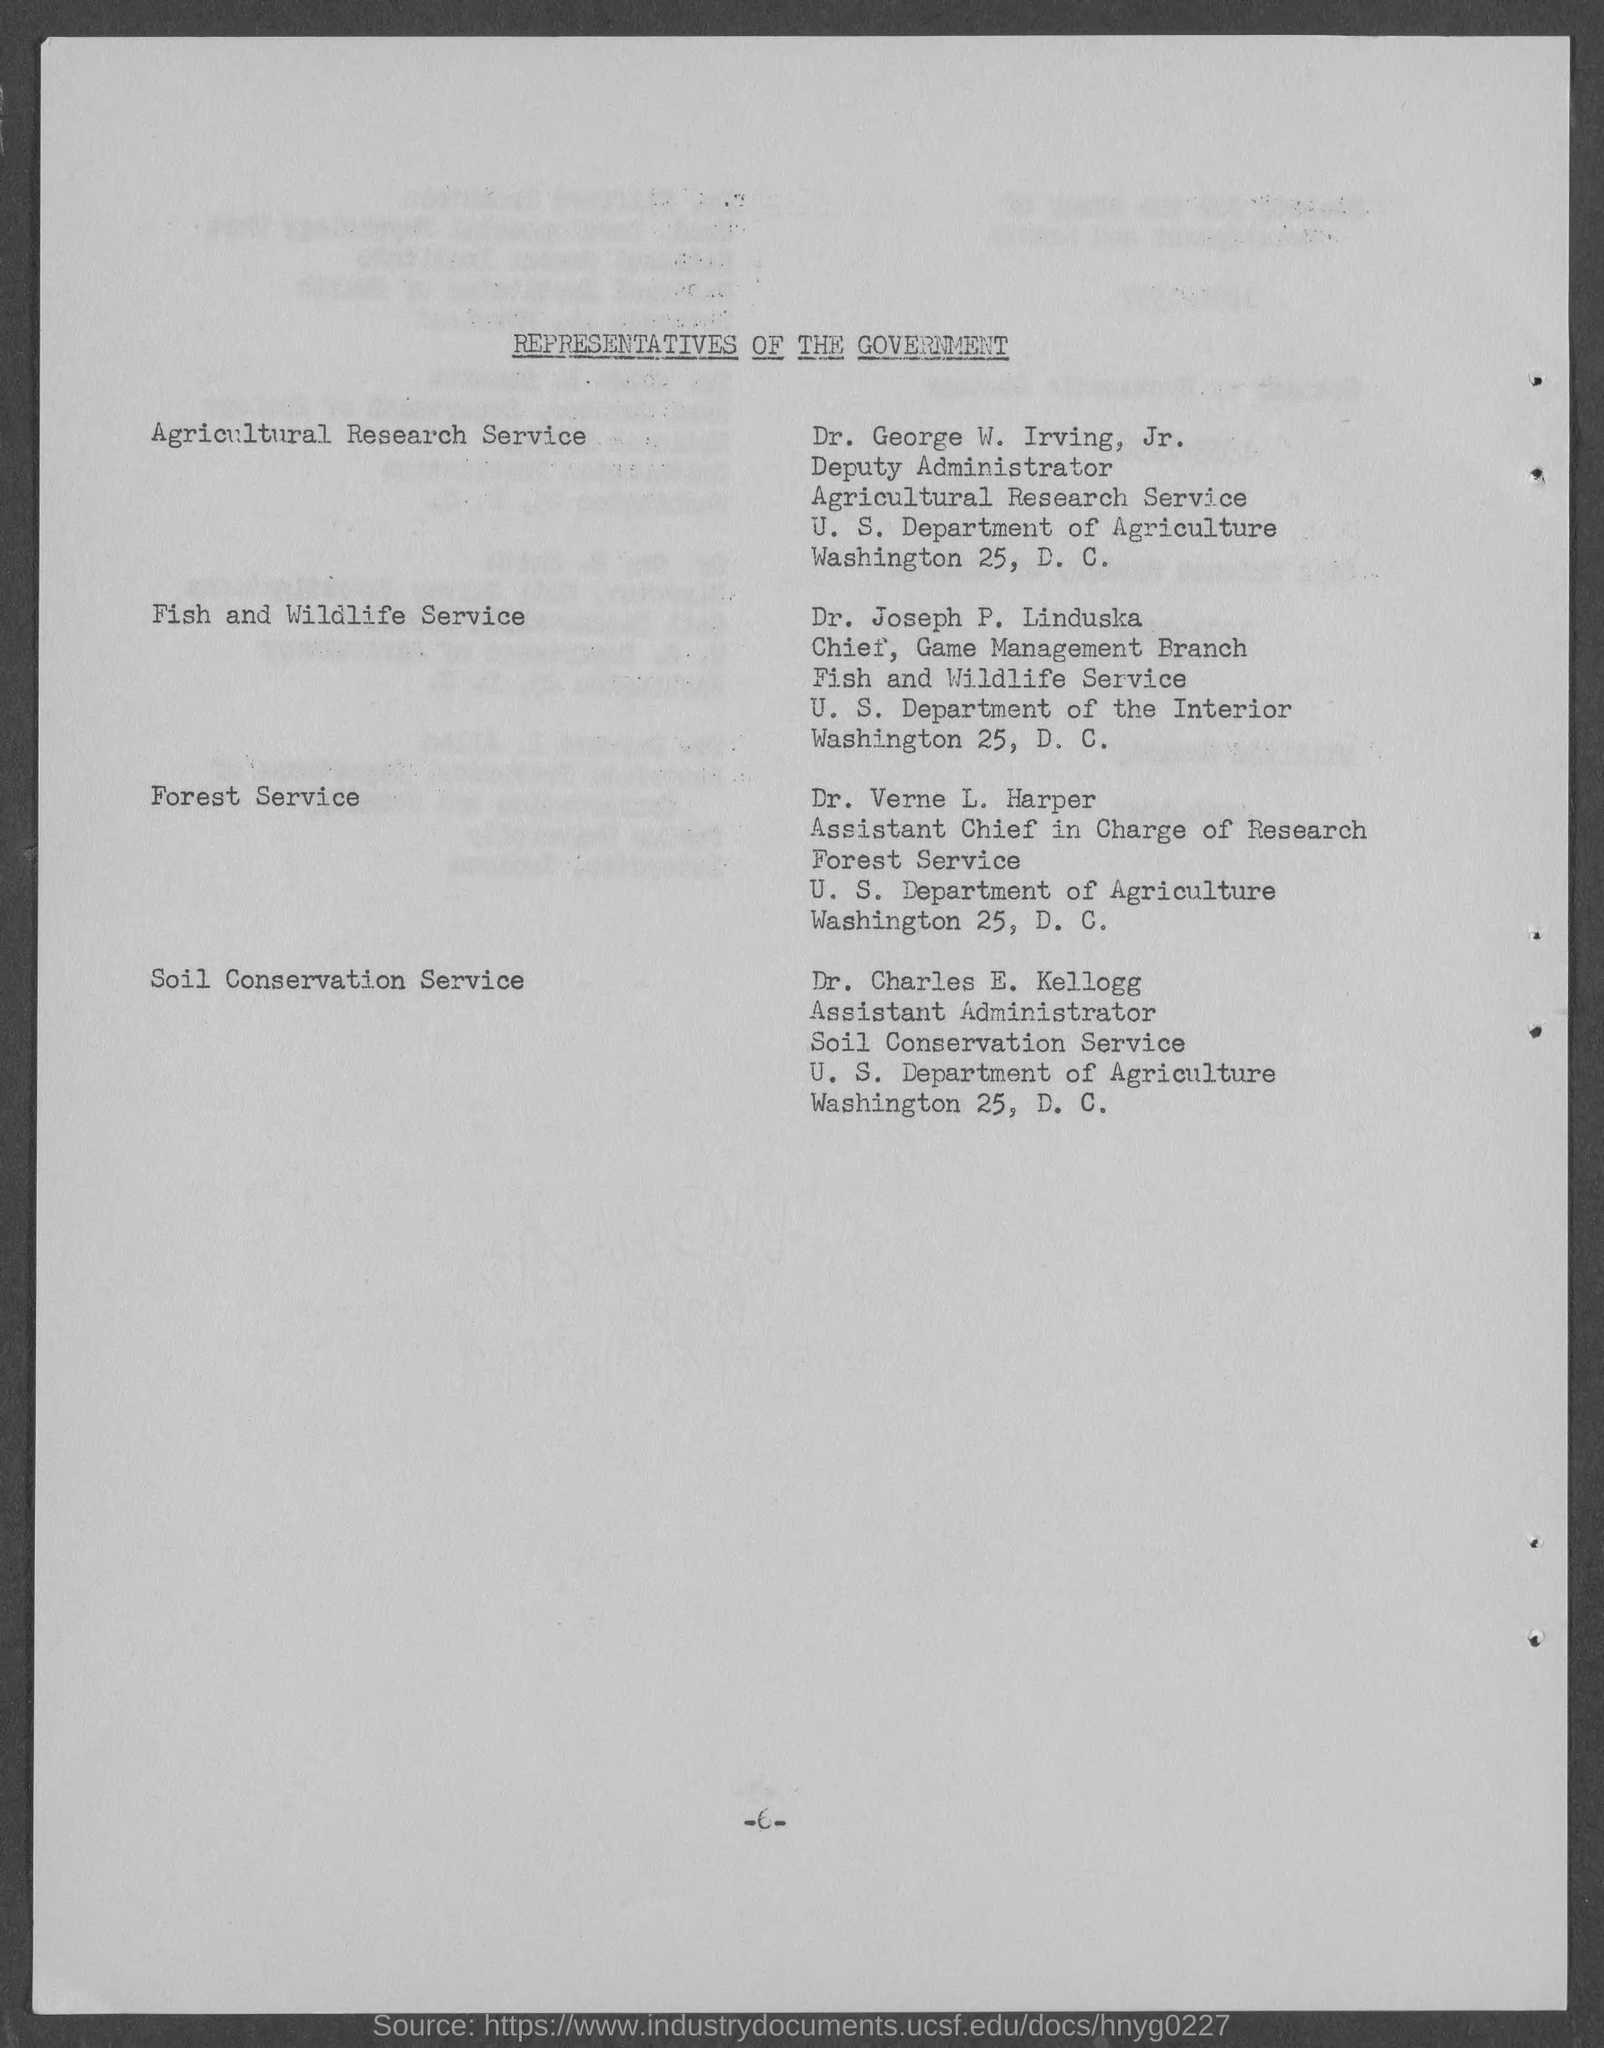What is the document title?
Provide a succinct answer. Representatives of the government. Who is the representative of Agricultural Research Service?
Your answer should be compact. Dr. George W. Irving, Jr. Who is Dr. Verne L. Harper of Forest Service?
Your response must be concise. Assistant Chief in Charge of Research. Who is the Assistant Administrator of Soil Conservation Service?
Offer a very short reply. Dr. Charles E. Kellogg. 